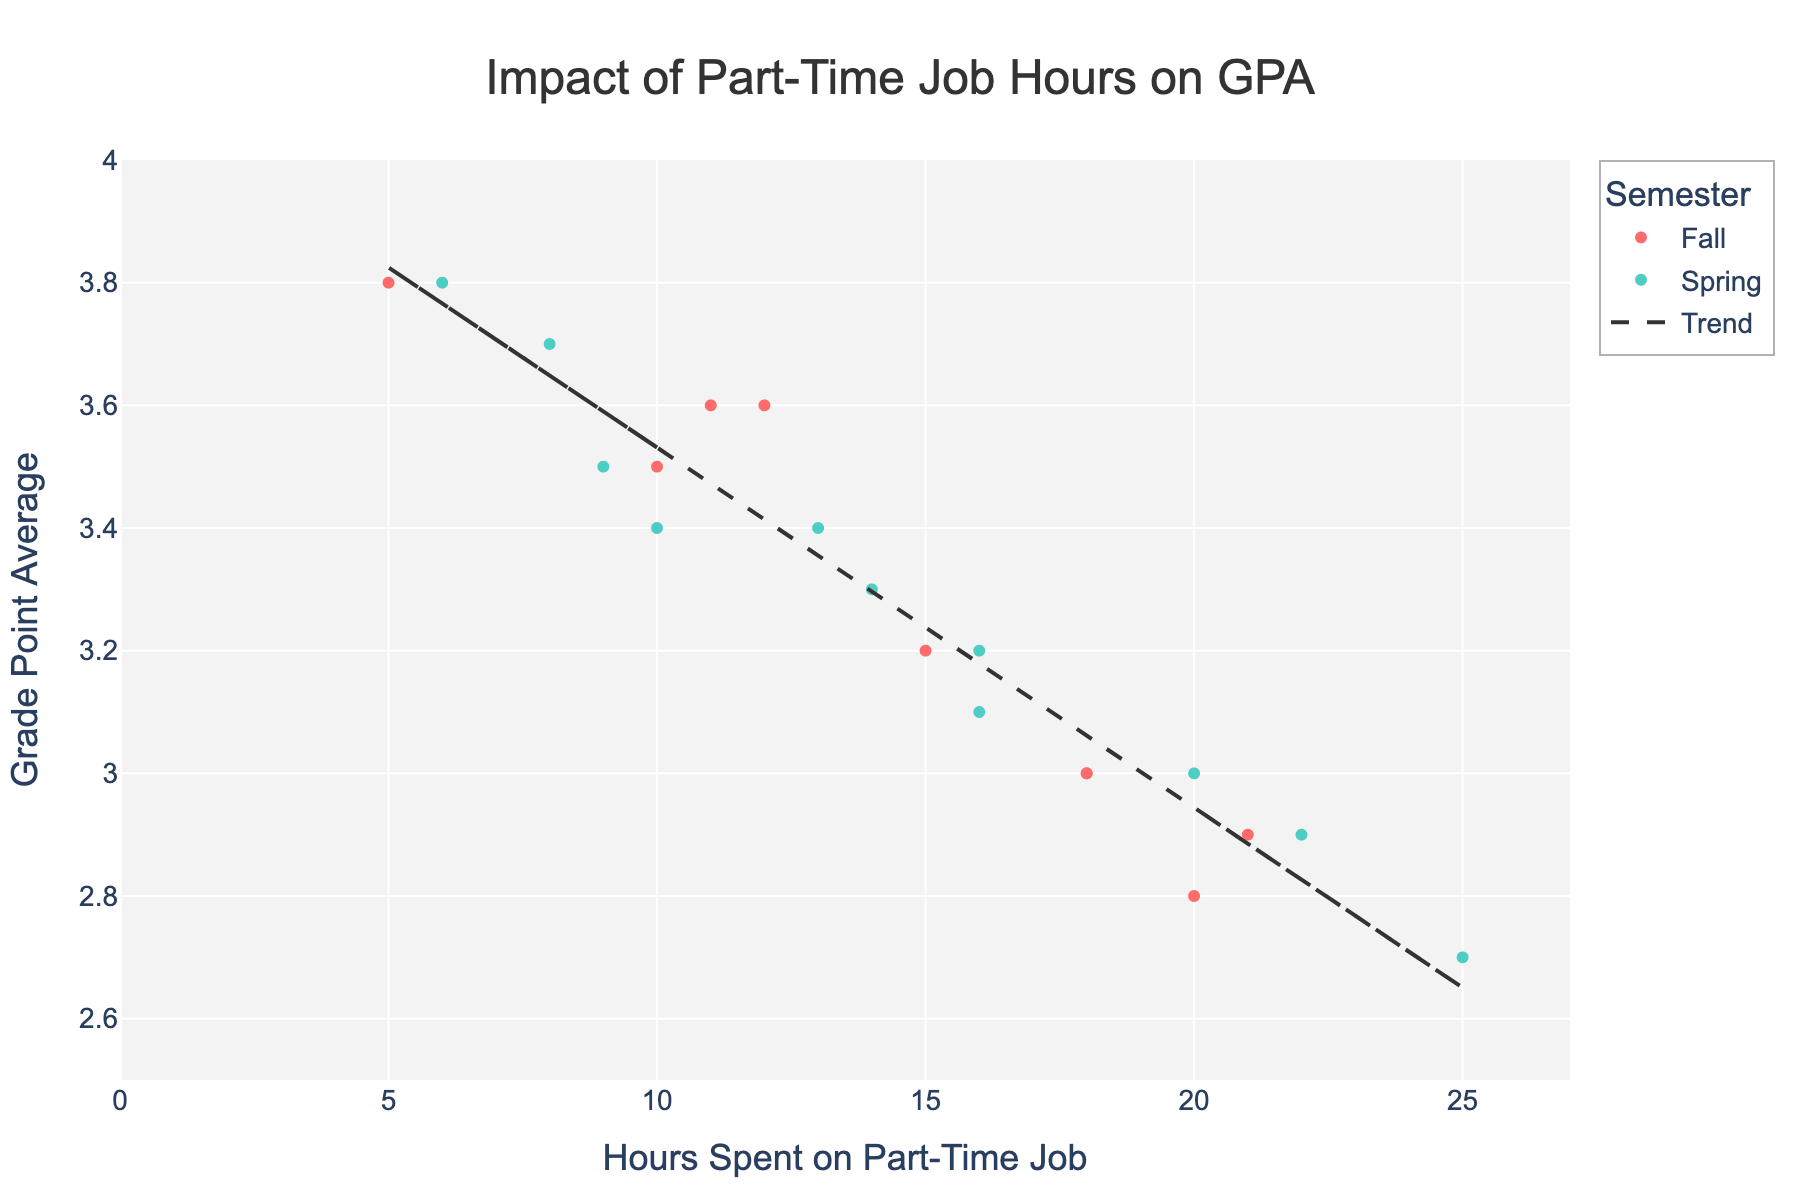What is the title of the figure? The title is written at the top center of the figure and reads 'Impact of Part-Time Job Hours on GPA'.
Answer: Impact of Part-Time Job Hours on GPA How many data points are in the Fall semester? The data points are represented by red dots, which are colored according to the semester. There are 9 red dots, corresponding to the Fall semester.
Answer: 9 How is the trend line represented in the figure? The trend line is shown as a dashed line going through the scatter plot. It represents the overall relationship between the hours spent on part-time jobs and GPA.
Answer: Dashed line Which semester tends to have students who spend more hours on part-time jobs? By looking at the scatter points, you can notice that the green dots, representing the Spring semester, are more concentrated towards the higher hours on the x-axis.
Answer: Spring What is the range of GPAs shown in the figure? The GPA values range from just below 2.7 to 3.8, as evident from the y-axis labels and the distribution of the data points.
Answer: 2.7 to 3.8 Compare the GPA of the students who work 10 hours in both semesters. Which semester has higher GPA for this group? By checking the data points at 10 hours on the x-axis, you can see that the GPA for Fall is higher than Spring. Alice Johnson has a GPA of 3.5 while George Allen has 3.4. Thus, the Fall semester has a higher GPA for this group.
Answer: Fall How does the GPA change as the hours spent on part-time jobs increase? Observe the trend line; it shows a downward slope, indicating that generally, GPA tends to decrease as the hours spent on part-time jobs increase.
Answer: Decreases Which student has the highest GPA, and how many hours do they spend on part-time work? The highest GPA in the scatter plot is 3.8. Charlie Davis (Fall) spends 5 hours and Samuel King (Spring) spends 6 hours on part-time jobs.
Answer: Charlie Davis (5 hours) and Samuel King (6 hours) What is the average GPA for students who work 20 hours in the Fall semester? There are two students who work 20 hours in the Fall semester (Diana Torres with 2.8 GPA and Paula Walker with 2.9 GPA). The average GPA is calculated as (2.8 + 2.9) / 2 = 2.85
Answer: 2.85 